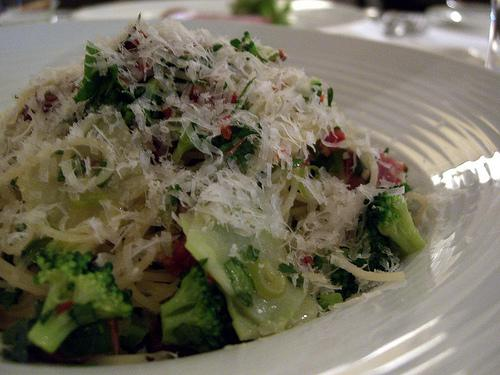Question: where is the picture taken?
Choices:
A. A kitchen.
B. The parking lot.
C. At a restaurant.
D. On the street.
Answer with the letter. Answer: C Question: what is seen in the plate?
Choices:
A. Steak.
B. Salad.
C. Fries.
D. Salad dressing.
Answer with the letter. Answer: B Question: what veggie is green in color?
Choices:
A. Collard greens.
B. Bok choy.
C. Broccoli.
D. Kale.
Answer with the letter. Answer: C Question: what is the color of the plate?
Choices:
A. Tan.
B. Brown.
C. White.
D. Red.
Answer with the letter. Answer: C 